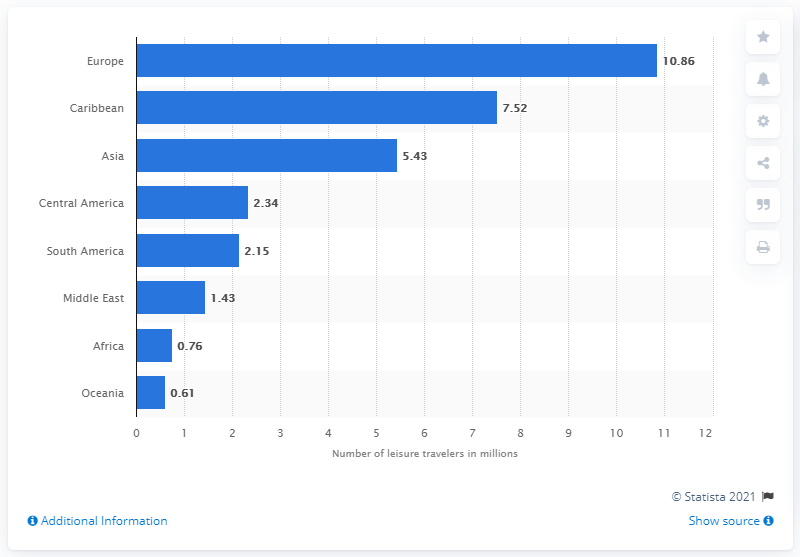Specify some key components in this picture. In 2016, there were 5.43 million outbound leisure travelers from the United States who traveled to Asia. 